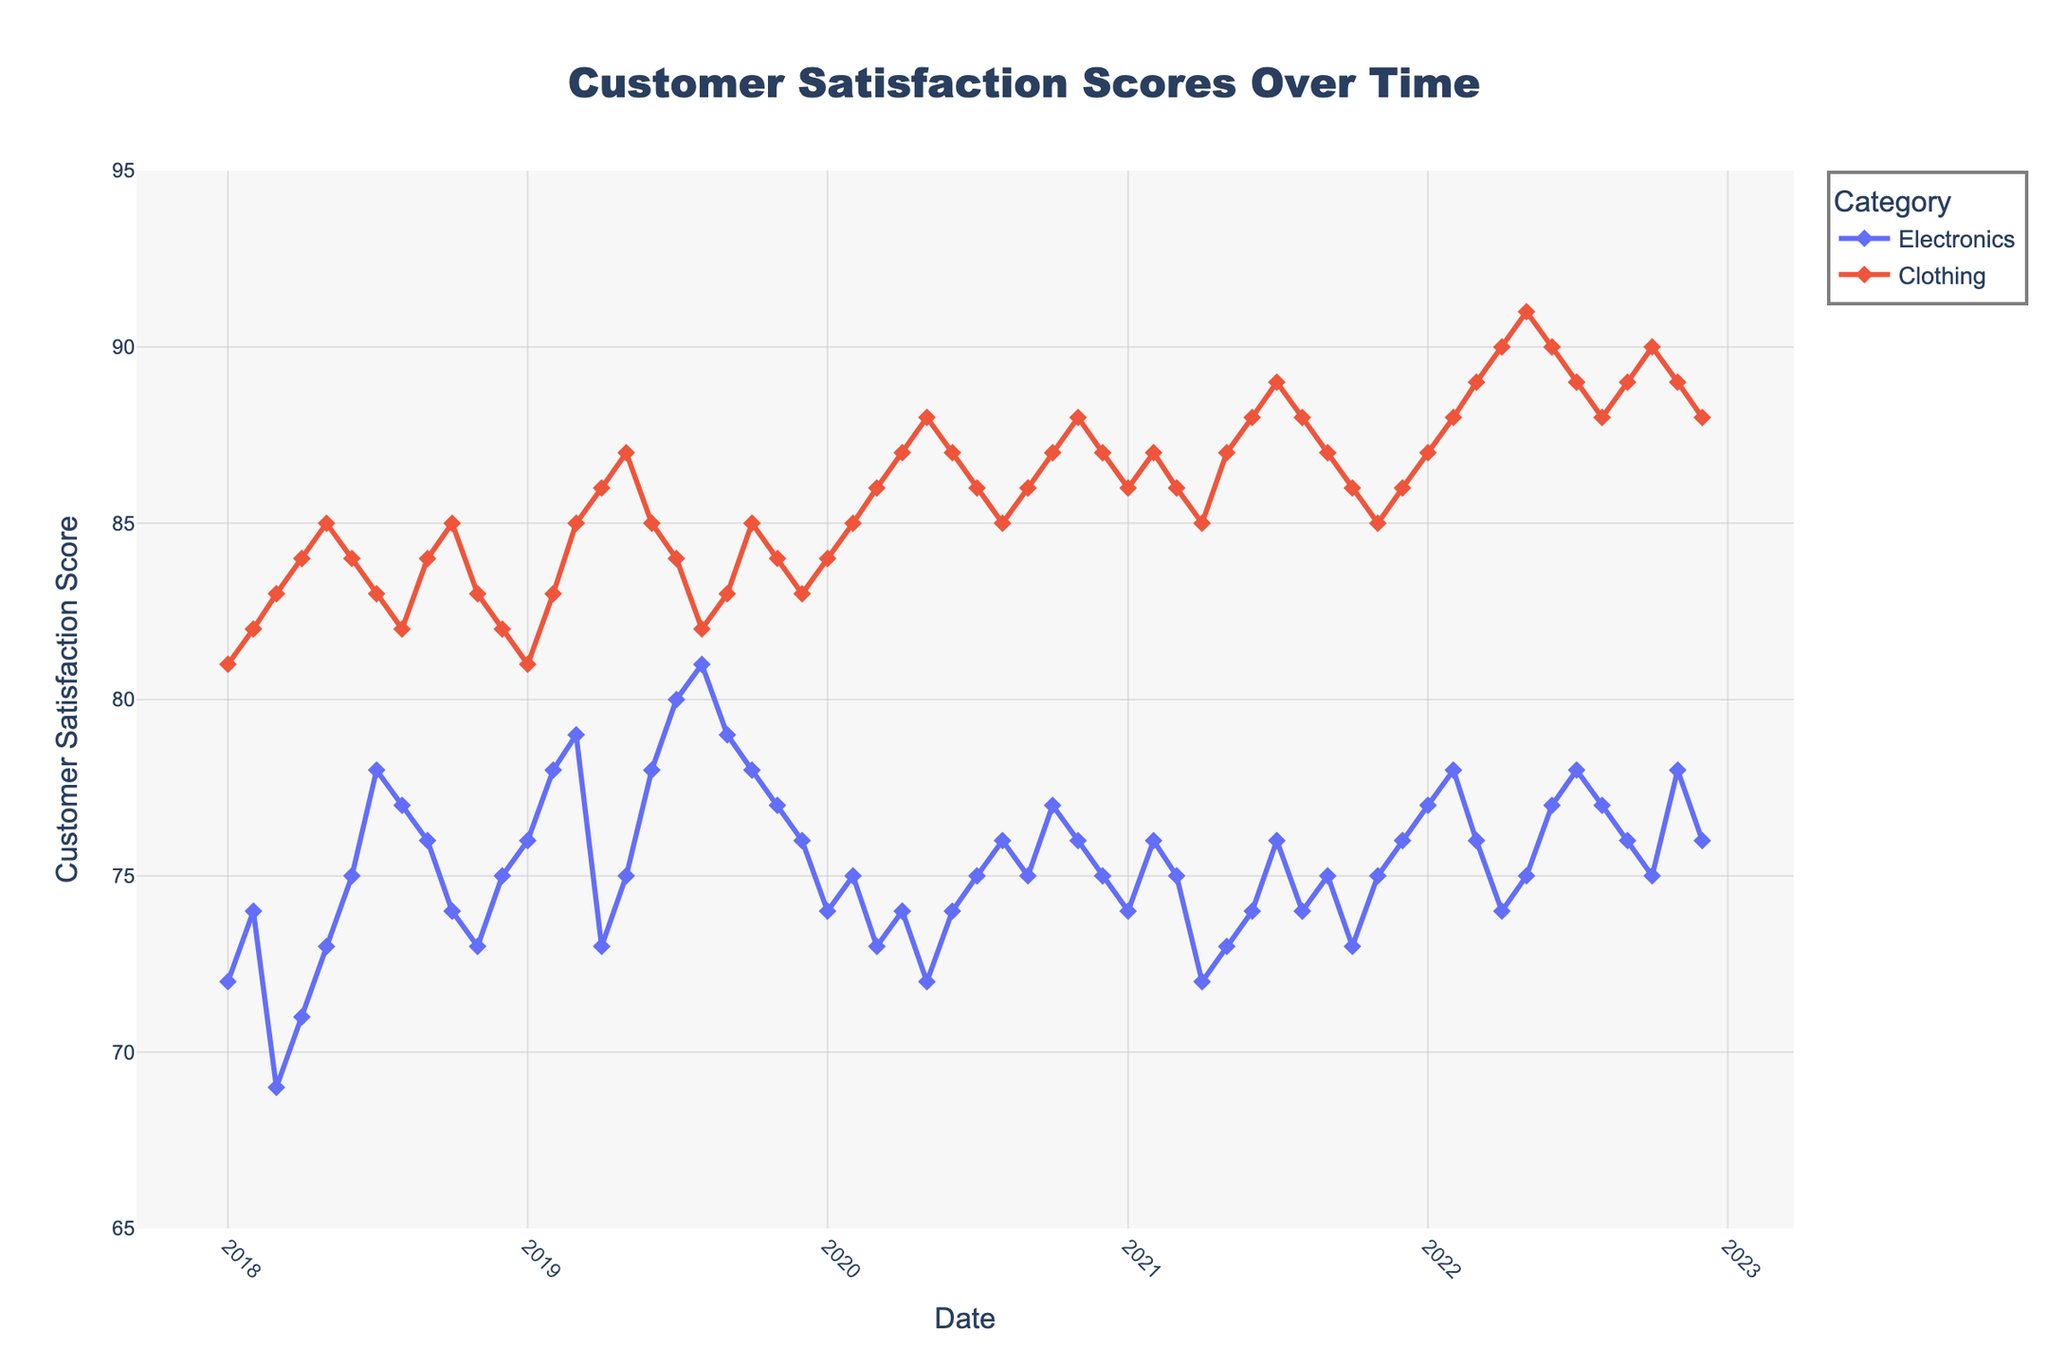What's the title of the plot? The title is prominently displayed at the top center of the plot. It reads "Customer Satisfaction Scores Over Time".
Answer: Customer Satisfaction Scores Over Time What is the range of the y-axis? The y-axis displays the range from 65 to 95, as shown by the labeled axis values.
Answer: 65 to 95 How many service categories are presented in the plot? Each unique color and marker in the legend corresponds to a different service category. The plot presents 2 categories: Electronics and Clothing.
Answer: 2 Which category has the highest satisfaction score in December 2020? To find this, locate December 2020 on the x-axis and compare the y-values for each category. The Clothing category has the highest score, as it reaches 87, compared to Electronics which is at 75.
Answer: Clothing Did the Electronics category ever reach a score of 80 or above? You can trace through the Electronics line and see that it reached 80 in July 2019 and went slightly above 80 in August 2019.
Answer: Yes What is the trend of the customer satisfaction score for the Electronics category from January 2021 to December 2021? Observe the line for the Electronics category from January 2021 to December 2021. The scores fluctuate slightly but overall, it does not show a significant upward or downward trend, staying mostly in the mid-70s range.
Answer: Relatively stable Which month and year had the lowest customer satisfaction score for Electronics across the entire time period? Trace the line of the Electronics category to find the minimum point, which is in March 2018 with a score of 69.
Answer: March 2018 Calculate the average customer satisfaction score for the Clothing category in the year 2020. Extract the data points for Clothing in 2020 and average them: (84, 85, 86, 87, 88, 87, 86, 85, 86, 87, 88, 87). Sum is 1023 and there are 12 points, so 1023/12 ≈ 85.25.
Answer: 85.25 Which category shows the greatest variability in customer satisfaction scores over the entire period? To determine variability, notice which category's line has the most fluctuations. The Clothing category consistently varies more noticeably than Electronics, especially with higher peaks and troughs.
Answer: Clothing 